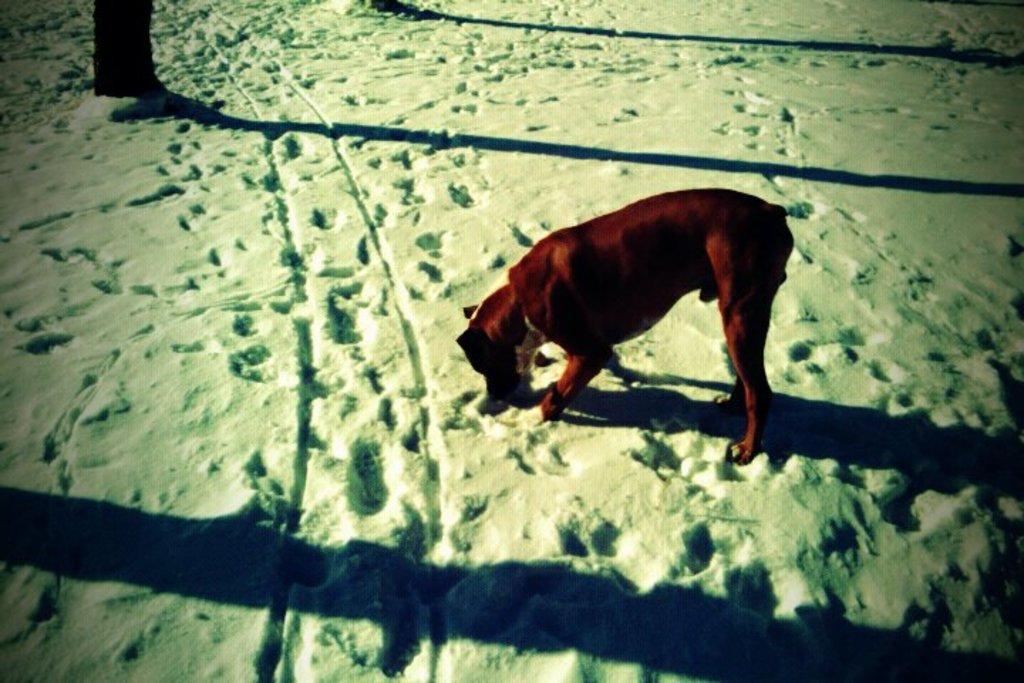How would you summarize this image in a sentence or two? In the center of the image, we can see an animal on the snow and we can see some shadows. 